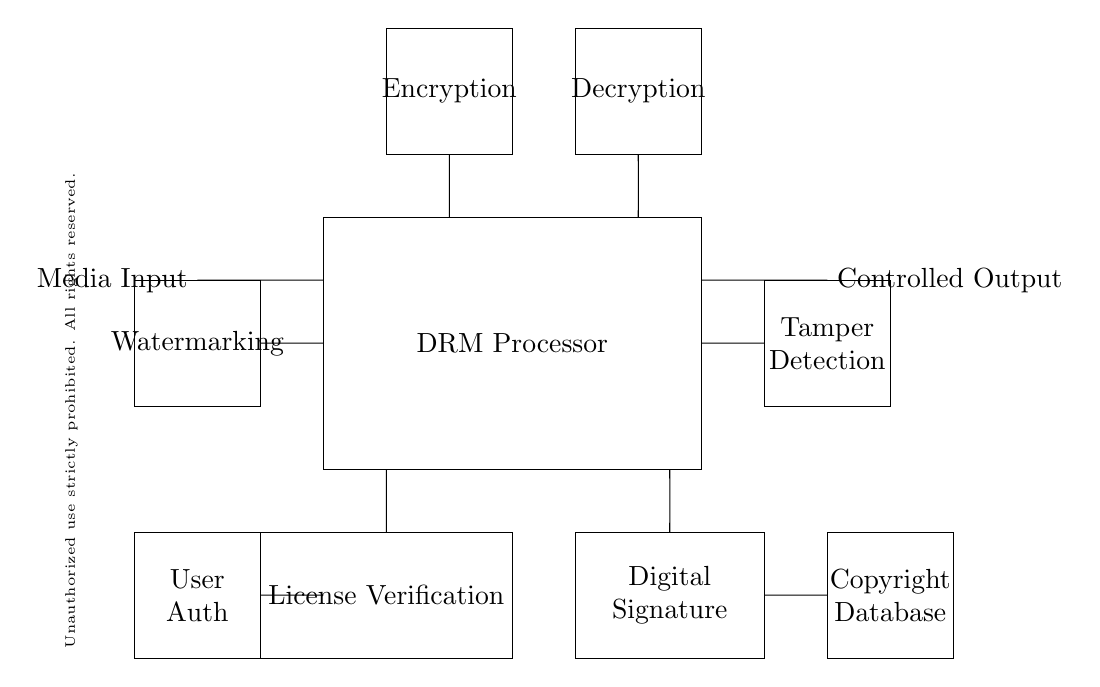What component is responsible for encryption? The component labeled "Encryption" located at the top of the DRM processor indicates its role in encrypting the media data.
Answer: Encryption What is located to the right of the Decryption module? The next component after the Decryption module is the Controlled Output, suggesting the flow of processed media data out of the circuit.
Answer: Controlled Output How many total modules are shown in the circuit? There are six distinct modules in the circuit diagram, namely: Encryption, Decryption, License Verification, Digital Signature, Tamper Detection, and Watermarking.
Answer: Six What is the purpose of the License Verification module? The License Verification module is meant to confirm user permissions for accessing or playing the media, ensuring that only authorized users can utilize the content.
Answer: Confirm permissions What does the Tamper Detection module do? The Tamper Detection module is designed to identify any unauthorized alterations or breaches within the DRM device, protecting content integrity.
Answer: Identify tampering What is the main processing unit in this circuit? The main processing unit in this circuit is the DRM Processor, which integrates all functionalities required for managing digital rights.
Answer: DRM Processor What message is indicated by the Legal Notice? The Legal Notice indicates that unauthorized use of the content is strictly prohibited and that all rights are reserved, signaling a warning to the user regarding copyright infringement.
Answer: Unauthorized use prohibited 